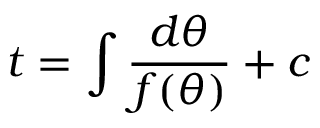<formula> <loc_0><loc_0><loc_500><loc_500>t = \int \frac { d \theta } { f ( \theta ) } + c</formula> 